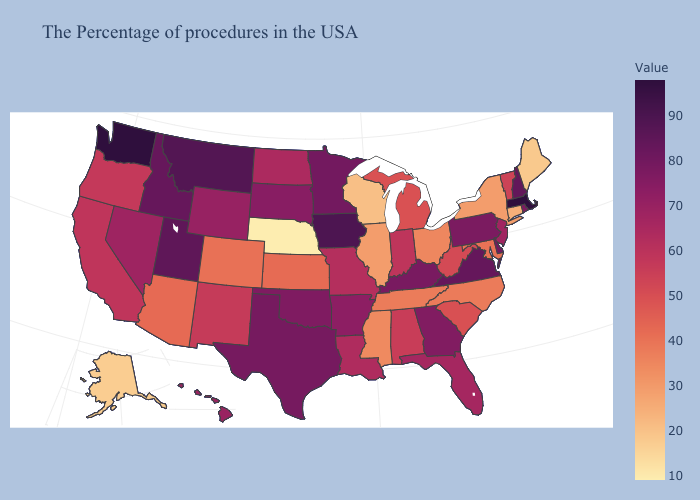Is the legend a continuous bar?
Be succinct. Yes. Among the states that border Kansas , does Missouri have the lowest value?
Write a very short answer. No. Among the states that border California , which have the highest value?
Give a very brief answer. Nevada. Does Colorado have the lowest value in the USA?
Be succinct. No. Does Missouri have a higher value than South Carolina?
Write a very short answer. Yes. Among the states that border Florida , does Alabama have the highest value?
Quick response, please. No. Among the states that border Wyoming , which have the lowest value?
Short answer required. Nebraska. 